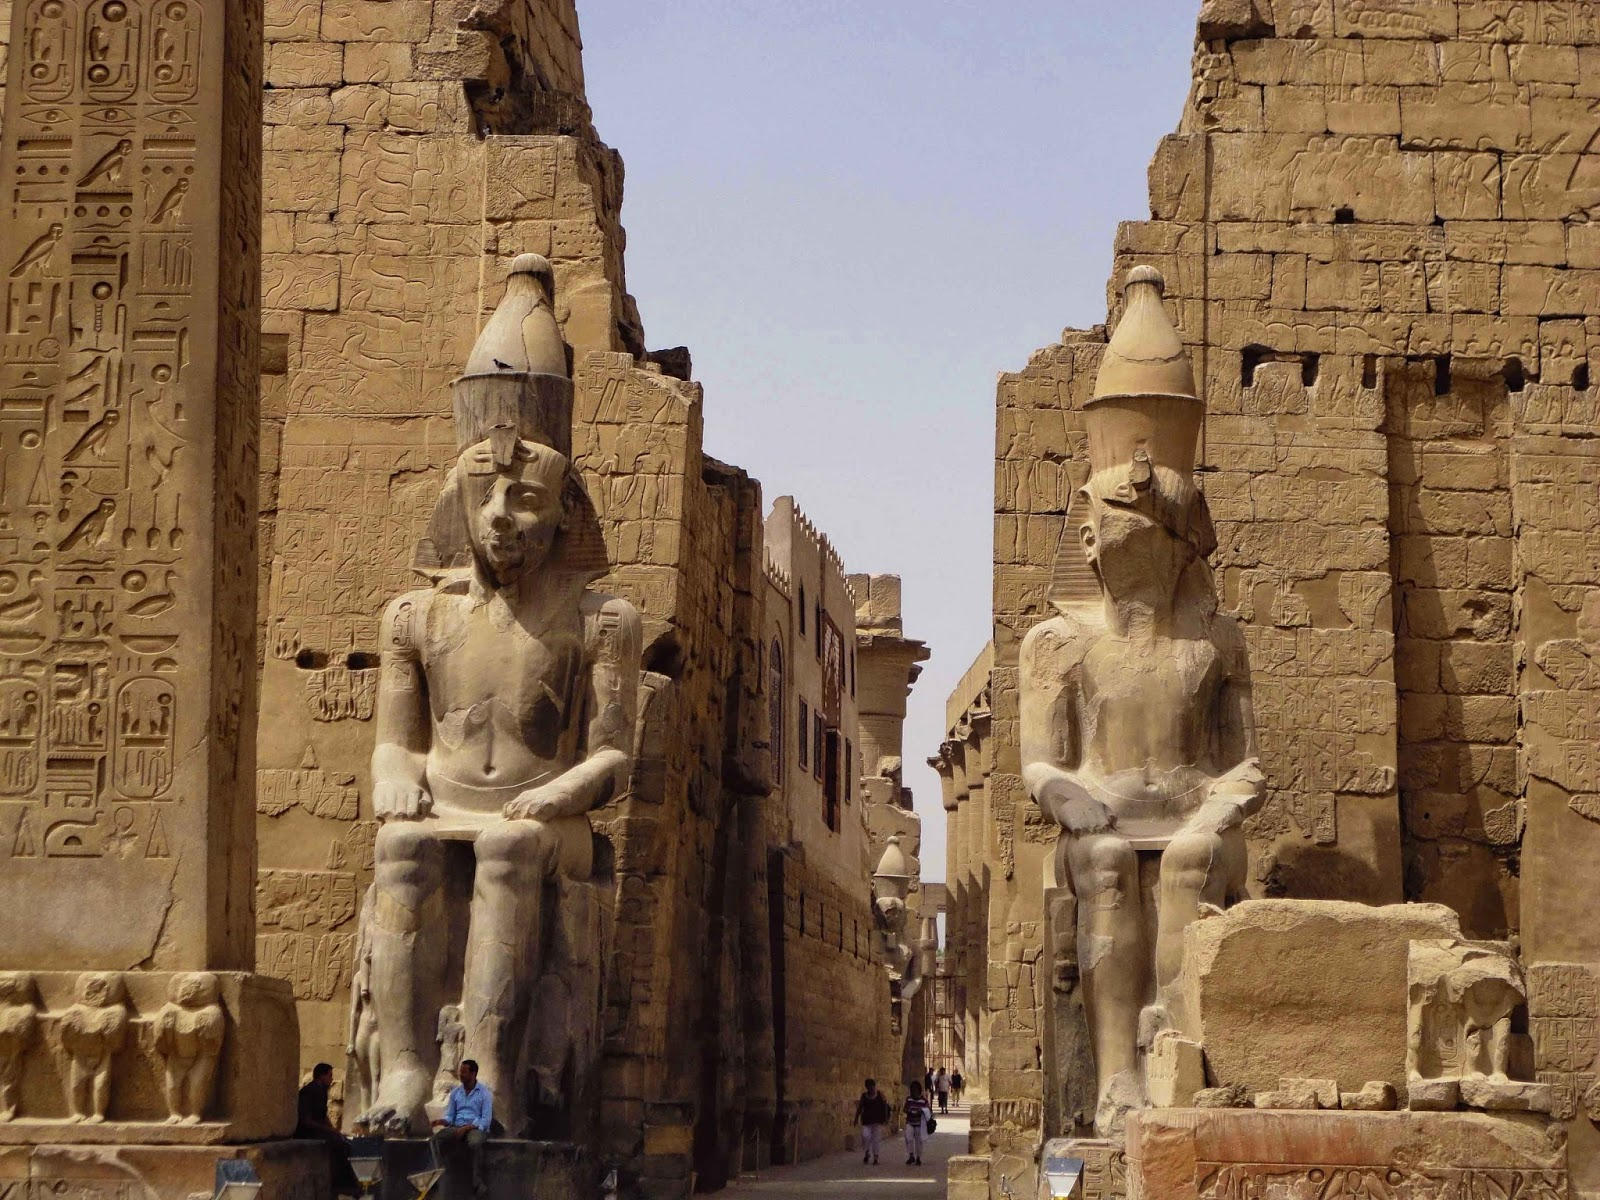Imagine a bustling marketplace here in ancient times. Envision Luxor Temple's courtyard transformed into a lively marketplace. Stalls brimming with exotic spices, vibrant textiles, and intricately crafted jewelry line the pathways. Merchants call out, extolling the virtues of their wares. The air is thick with the scent of incense and the sounds of bartering. Musicians play traditional instruments, adding rhythm to the hum of activity. Locals and travelers alike fill the space, exchanging goods and stories. Amidst this hive of activity, the grandeur of the temple remains, blending the sacred and the everyday in a dynamic tapestry of ancient Egyptian life. 